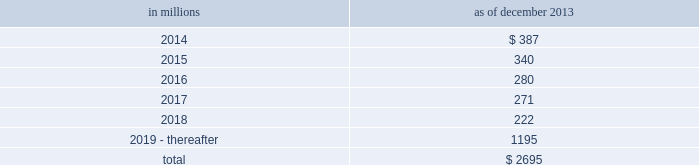Notes to consolidated financial statements sumitomo mitsui financial group , inc .
( smfg ) provides the firm with credit loss protection on certain approved loan commitments ( primarily investment-grade commercial lending commitments ) .
The notional amount of such loan commitments was $ 29.24 billion and $ 32.41 billion as of december 2013 and december 2012 , respectively .
The credit loss protection on loan commitments provided by smfg is generally limited to 95% ( 95 % ) of the first loss the firm realizes on such commitments , up to a maximum of approximately $ 950 million .
In addition , subject to the satisfaction of certain conditions , upon the firm 2019s request , smfg will provide protection for 70% ( 70 % ) of additional losses on such commitments , up to a maximum of $ 1.13 billion , of which $ 870 million and $ 300 million of protection had been provided as of december 2013 and december 2012 , respectively .
The firm also uses other financial instruments to mitigate credit risks related to certain commitments not covered by smfg .
These instruments primarily include credit default swaps that reference the same or similar underlying instrument or entity , or credit default swaps that reference a market index .
Warehouse financing .
The firm provides financing to clients who warehouse financial assets .
These arrangements are secured by the warehoused assets , primarily consisting of corporate loans and commercial mortgage loans .
Contingent and forward starting resale and securities borrowing agreements/forward starting repurchase and secured lending agreements the firm enters into resale and securities borrowing agreements and repurchase and secured lending agreements that settle at a future date , generally within three business days .
The firm also enters into commitments to provide contingent financing to its clients and counterparties through resale agreements .
The firm 2019s funding of these commitments depends on the satisfaction of all contractual conditions to the resale agreement and these commitments can expire unused .
Investment commitments the firm 2019s investment commitments consist of commitments to invest in private equity , real estate and other assets directly and through funds that the firm raises and manages .
These commitments include $ 659 million and $ 872 million as of december 2013 and december 2012 , respectively , related to real estate private investments and $ 6.46 billion and $ 6.47 billion as of december 2013 and december 2012 , respectively , related to corporate and other private investments .
Of these amounts , $ 5.48 billion and $ 6.21 billion as of december 2013 and december 2012 , respectively , relate to commitments to invest in funds managed by the firm .
If these commitments are called , they would be funded at market value on the date of investment .
Leases the firm has contractual obligations under long-term noncancelable lease agreements , principally for office space , expiring on various dates through 2069 .
Certain agreements are subject to periodic escalation provisions for increases in real estate taxes and other charges .
The table below presents future minimum rental payments , net of minimum sublease rentals .
In millions december 2013 .
Rent charged to operating expense was $ 324 million for 2013 , $ 374 million for 2012 and $ 475 million for 2011 .
Operating leases include office space held in excess of current requirements .
Rent expense relating to space held for growth is included in 201coccupancy . 201d the firm records a liability , based on the fair value of the remaining lease rentals reduced by any potential or existing sublease rentals , for leases where the firm has ceased using the space and management has concluded that the firm will not derive any future economic benefits .
Costs to terminate a lease before the end of its term are recognized and measured at fair value on termination .
Contingencies legal proceedings .
See note 27 for information about legal proceedings , including certain mortgage-related matters .
Certain mortgage-related contingencies .
There are multiple areas of focus by regulators , governmental agencies and others within the mortgage market that may impact originators , issuers , servicers and investors .
There remains significant uncertainty surrounding the nature and extent of any potential exposure for participants in this market .
182 goldman sachs 2013 annual report .
What percentage of future minimum rental payments are due in 2015? 
Computations: (340 / 2695)
Answer: 0.12616. 